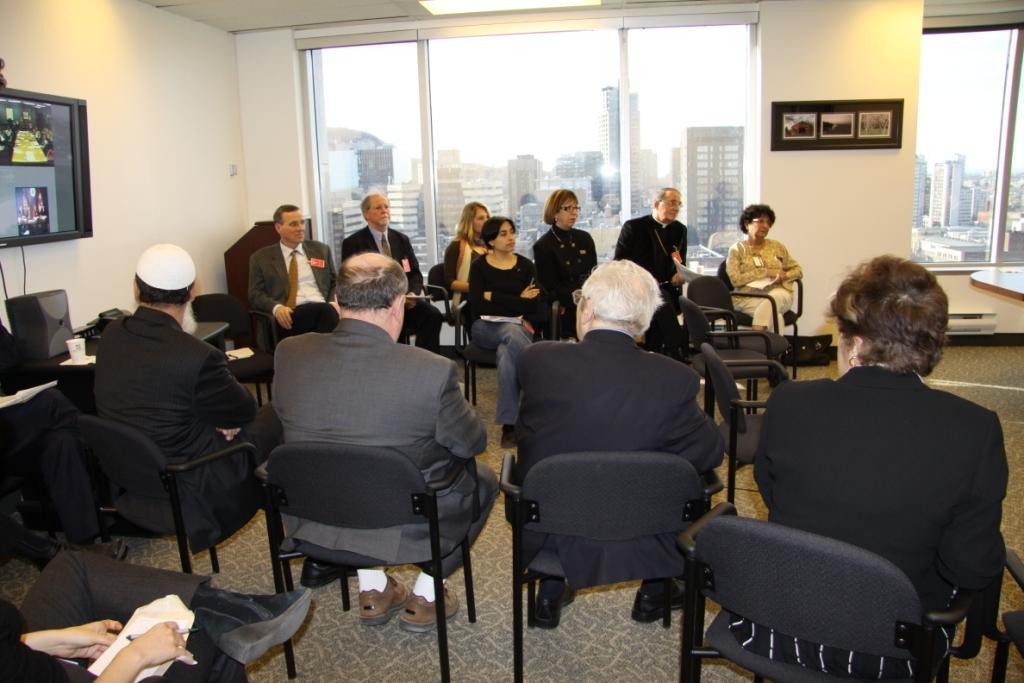Describe this image in one or two sentences. In this image there are a group of people sitting on chairs, behind them there are some photo frames on the wall and TV on the other side, also there is a glass wall from which we can see view of the buildings outside. 